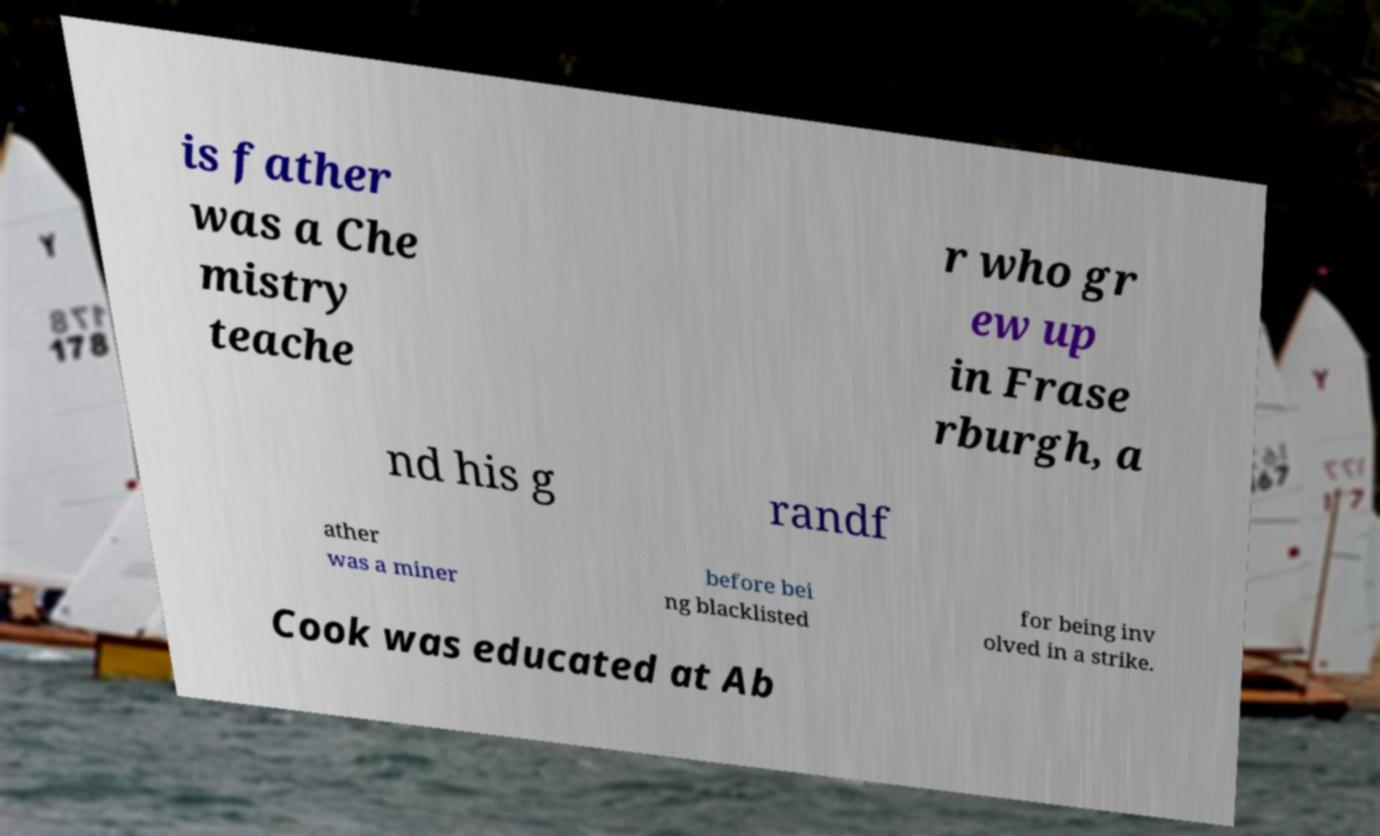Can you accurately transcribe the text from the provided image for me? is father was a Che mistry teache r who gr ew up in Frase rburgh, a nd his g randf ather was a miner before bei ng blacklisted for being inv olved in a strike. Cook was educated at Ab 